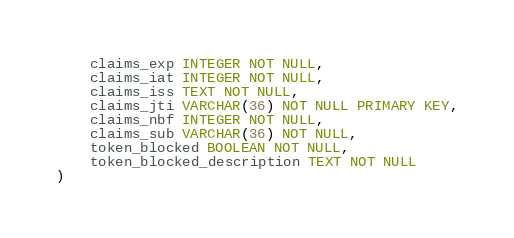<code> <loc_0><loc_0><loc_500><loc_500><_SQL_>    claims_exp INTEGER NOT NULL,
    claims_iat INTEGER NOT NULL,
    claims_iss TEXT NOT NULL,
    claims_jti VARCHAR(36) NOT NULL PRIMARY KEY,
    claims_nbf INTEGER NOT NULL,
    claims_sub VARCHAR(36) NOT NULL,
    token_blocked BOOLEAN NOT NULL,
    token_blocked_description TEXT NOT NULL
)
</code> 